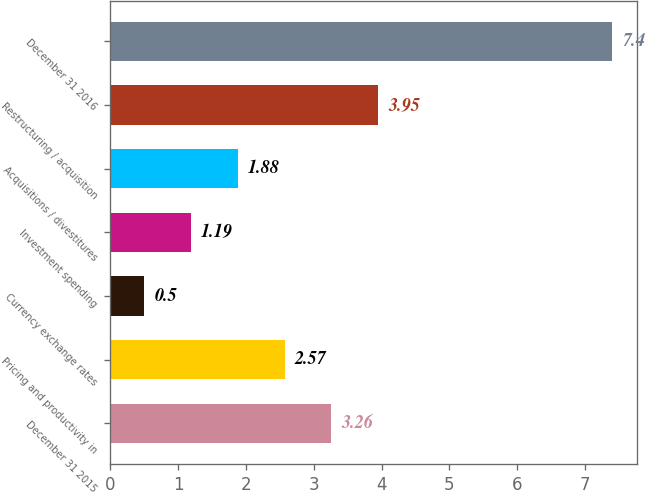<chart> <loc_0><loc_0><loc_500><loc_500><bar_chart><fcel>December 31 2015<fcel>Pricing and productivity in<fcel>Currency exchange rates<fcel>Investment spending<fcel>Acquisitions / divestitures<fcel>Restructuring / acquisition<fcel>December 31 2016<nl><fcel>3.26<fcel>2.57<fcel>0.5<fcel>1.19<fcel>1.88<fcel>3.95<fcel>7.4<nl></chart> 